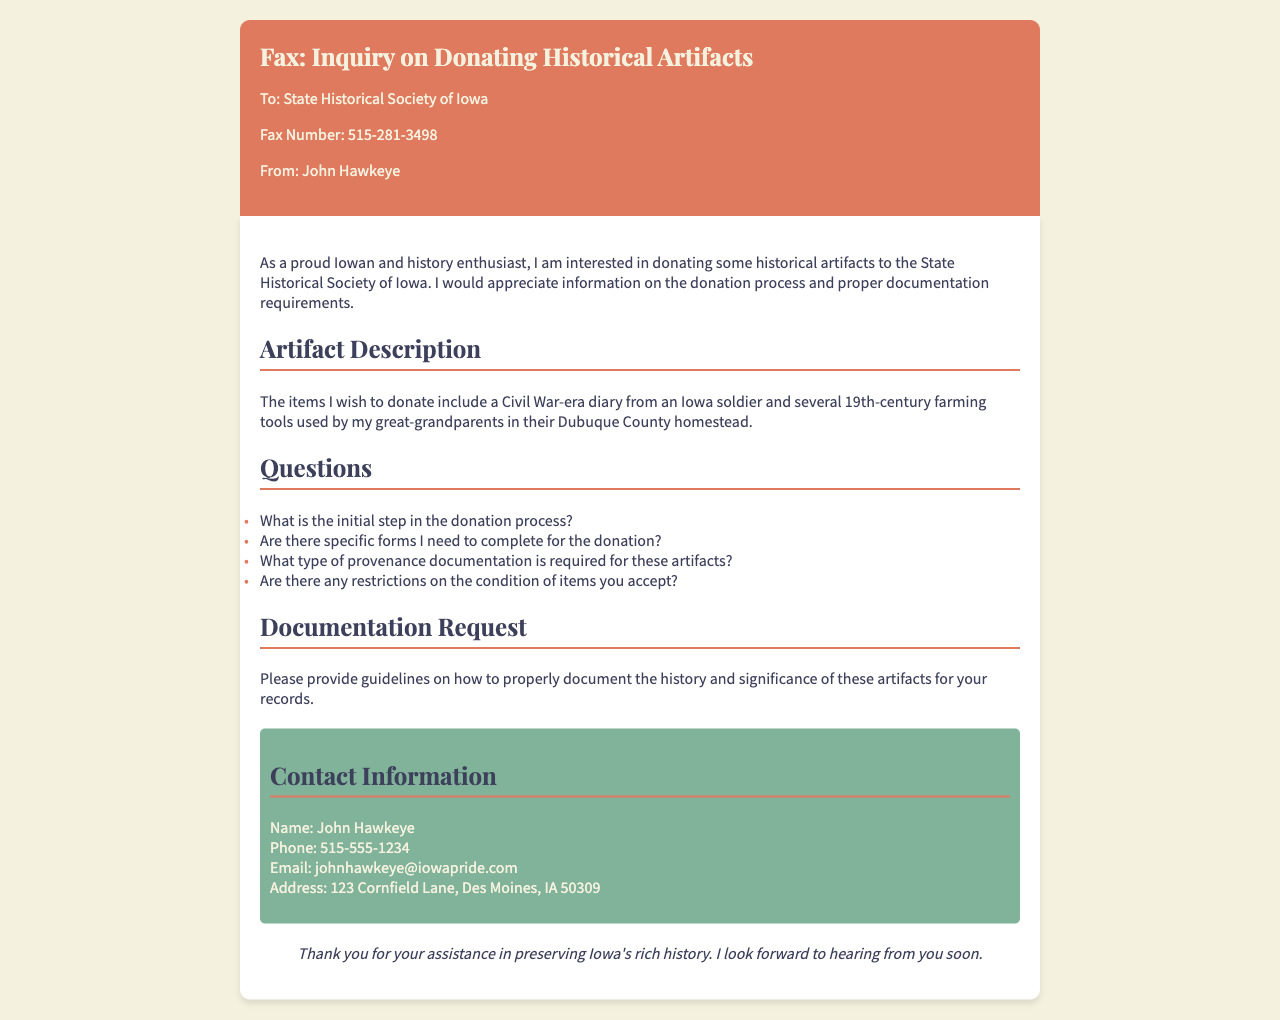What is the name of the sender? The sender's name is listed at the bottom of the document.
Answer: John Hawkeye What is the fax number of the State Historical Society of Iowa? The fax number is found in the header of the document.
Answer: 515-281-3498 What type of diary is being donated? The specific type of diary is mentioned in the description of the artifacts.
Answer: Civil War-era diary What county is mentioned regarding the farming tools? The county reference is provided in the context of the farming tools' history.
Answer: Dubuque County What is the phone number of the sender? The sender's contact information includes a phone number provided at the end.
Answer: 515-555-1234 What is requested for artifact documentation? The documentation request is found in a specific section of the document.
Answer: Guidelines How many artifacts does John want to donate? The number of artifacts is implied in the description given in the document.
Answer: Two What is the last sentence of the fax? The closing statement can be found in the last section before the sender's contact info.
Answer: Thank you for your assistance in preserving Iowa's rich history Are provenance documents required for donations? The question about provenance documentation is explicitly listed in the questions section.
Answer: Yes 